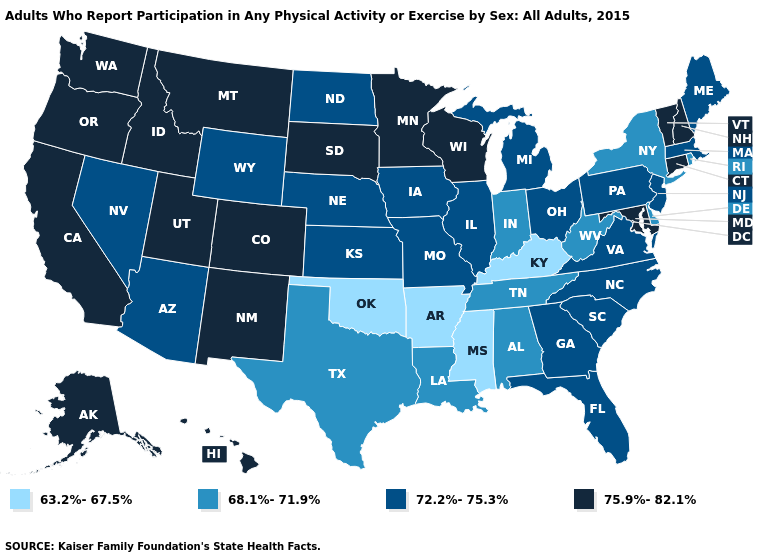What is the value of North Dakota?
Answer briefly. 72.2%-75.3%. What is the highest value in the MidWest ?
Keep it brief. 75.9%-82.1%. What is the value of Indiana?
Be succinct. 68.1%-71.9%. What is the lowest value in states that border Alabama?
Short answer required. 63.2%-67.5%. Which states have the lowest value in the MidWest?
Write a very short answer. Indiana. Which states have the highest value in the USA?
Answer briefly. Alaska, California, Colorado, Connecticut, Hawaii, Idaho, Maryland, Minnesota, Montana, New Hampshire, New Mexico, Oregon, South Dakota, Utah, Vermont, Washington, Wisconsin. What is the value of Mississippi?
Be succinct. 63.2%-67.5%. Does Arizona have the lowest value in the West?
Short answer required. Yes. Is the legend a continuous bar?
Quick response, please. No. What is the lowest value in the USA?
Short answer required. 63.2%-67.5%. Does South Dakota have the same value as Kansas?
Keep it brief. No. Does Colorado have the lowest value in the West?
Concise answer only. No. What is the value of Wisconsin?
Quick response, please. 75.9%-82.1%. What is the value of Idaho?
Concise answer only. 75.9%-82.1%. 